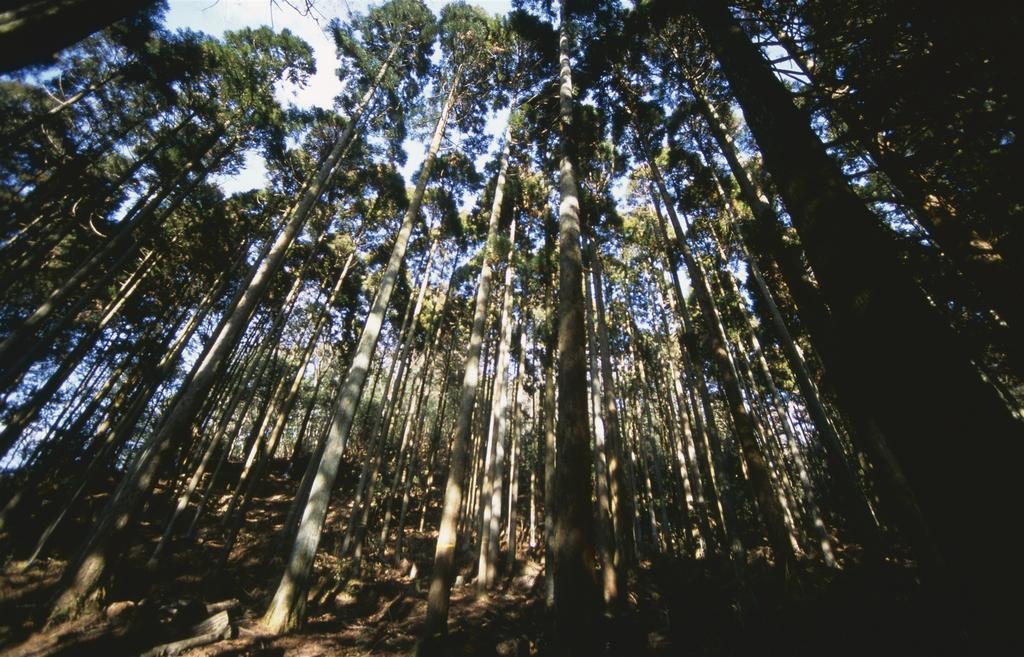Can you describe this image briefly? In this image we can see trees. In the background there is sky. 